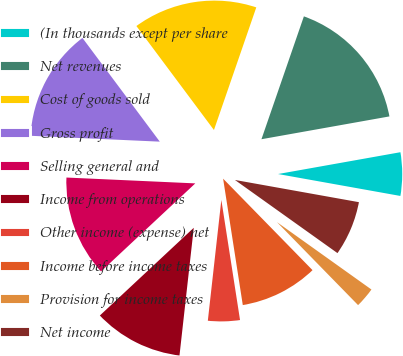<chart> <loc_0><loc_0><loc_500><loc_500><pie_chart><fcel>(In thousands except per share<fcel>Net revenues<fcel>Cost of goods sold<fcel>Gross profit<fcel>Selling general and<fcel>Income from operations<fcel>Other income (expense) net<fcel>Income before income taxes<fcel>Provision for income taxes<fcel>Net income<nl><fcel>5.63%<fcel>16.9%<fcel>15.49%<fcel>14.08%<fcel>12.68%<fcel>11.27%<fcel>4.23%<fcel>9.86%<fcel>2.82%<fcel>7.04%<nl></chart> 